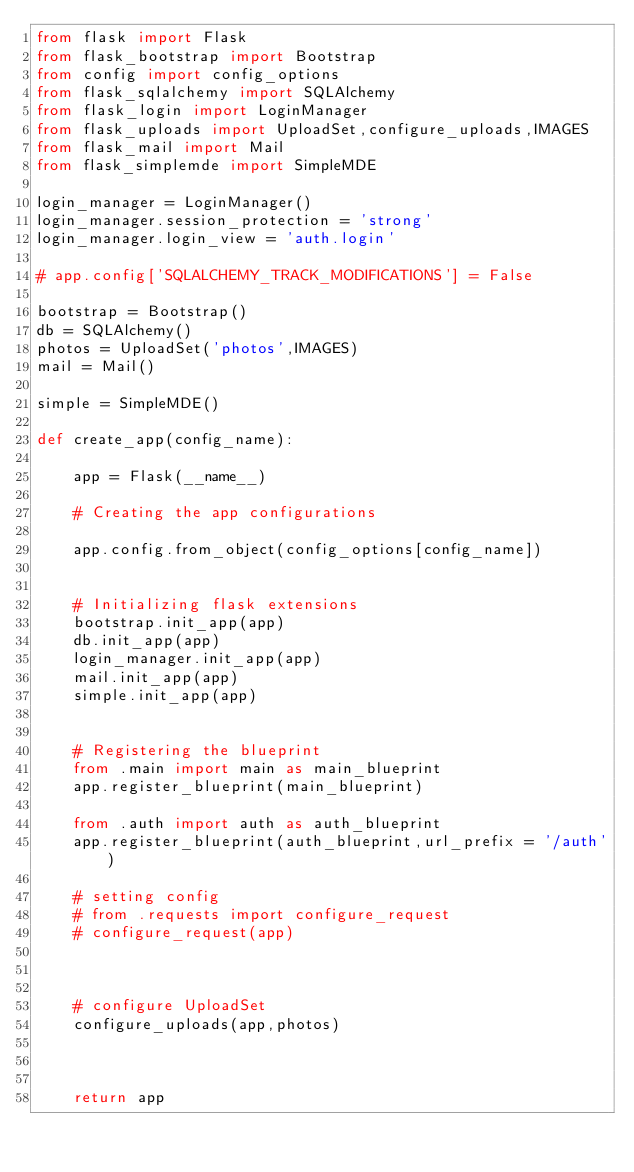<code> <loc_0><loc_0><loc_500><loc_500><_Python_>from flask import Flask
from flask_bootstrap import Bootstrap
from config import config_options
from flask_sqlalchemy import SQLAlchemy
from flask_login import LoginManager
from flask_uploads import UploadSet,configure_uploads,IMAGES
from flask_mail import Mail
from flask_simplemde import SimpleMDE

login_manager = LoginManager()
login_manager.session_protection = 'strong'
login_manager.login_view = 'auth.login'

# app.config['SQLALCHEMY_TRACK_MODIFICATIONS'] = False

bootstrap = Bootstrap()
db = SQLAlchemy()
photos = UploadSet('photos',IMAGES)
mail = Mail()

simple = SimpleMDE()

def create_app(config_name):

    app = Flask(__name__)

    # Creating the app configurations
    
    app.config.from_object(config_options[config_name])
    

    # Initializing flask extensions
    bootstrap.init_app(app)
    db.init_app(app)
    login_manager.init_app(app)
    mail.init_app(app)
    simple.init_app(app)


    # Registering the blueprint
    from .main import main as main_blueprint
    app.register_blueprint(main_blueprint)

    from .auth import auth as auth_blueprint
    app.register_blueprint(auth_blueprint,url_prefix = '/auth')

    # setting config
    # from .requests import configure_request
    # configure_request(app)



    # configure UploadSet
    configure_uploads(app,photos)

    

    return app</code> 